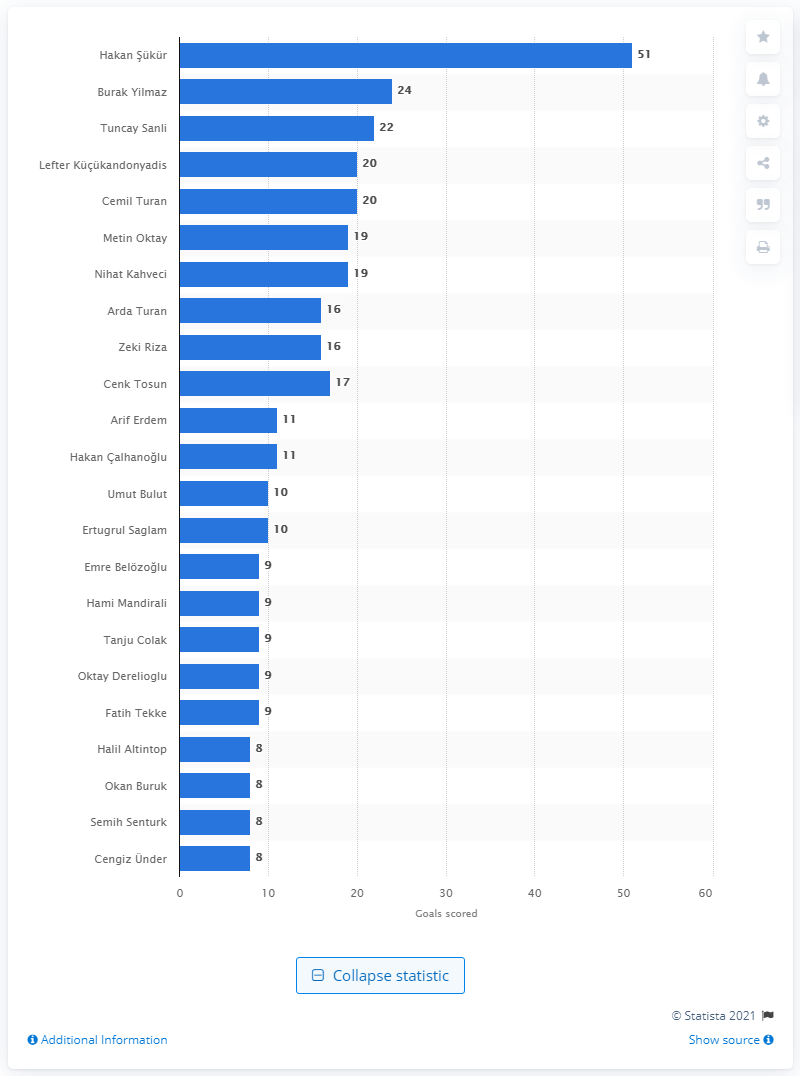Identify some key points in this picture. Hakan 14k14r has scored 51 goals for Turkey's national football team. Tuncay has scored 22 goals. Tuncay has scored 22 goals. 